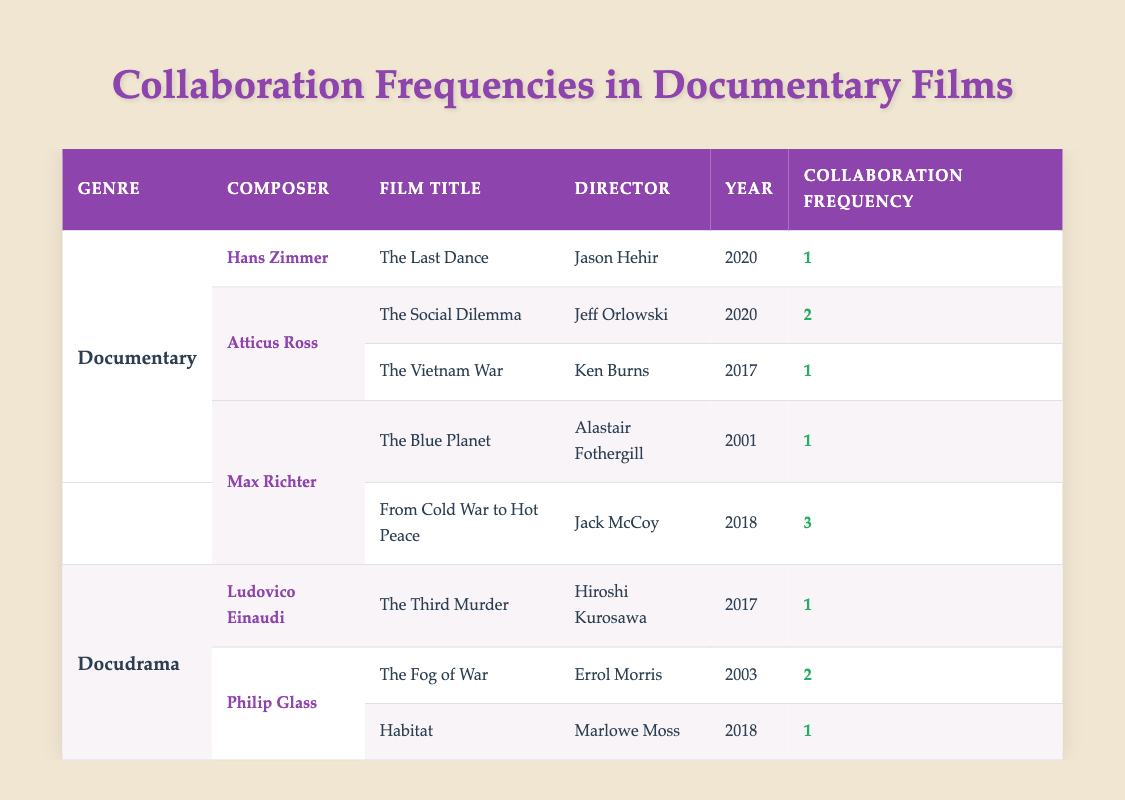What is the title of the film composed by Hans Zimmer? The table lists "The Last Dance" as the film composed by Hans Zimmer. This is found in the row corresponding to Hans Zimmer under the Documentary genre.
Answer: The Last Dance Which composer has worked on the film "The Fog of War"? The table shows that Philip Glass is the composer for "The Fog of War", which is listed in the row corresponding to Philip Glass under the Docudrama genre.
Answer: Philip Glass What is the collaboration frequency of Atticus Ross for "The Social Dilemma"? The table indicates a collaboration frequency of 2 for Atticus Ross on "The Social Dilemma", as noted in the corresponding cell under Collaboration Frequency.
Answer: 2 How many films did Max Richter score, and what is the total collaboration frequency? Max Richter scored 2 films: "The Blue Planet" (1) and "From Cold War to Hot Peace" (3). Adding these together, the total collaboration frequency is 1 + 3 = 4.
Answer: 4 Did Ludovico Einaudi collaborate with more than one filmmaker? The data shows that Ludovico Einaudi collaborated on only one film, "The Third Murder", thus the answer is no.
Answer: No Which composer has the highest collaboration frequency in the table, and what is that value? By examining the Collaboration Frequency values, Max Richter has the highest frequency of 3 for "From Cold War to Hot Peace". This is the max value among all frequencies listed.
Answer: 3 How many years apart were the documentaries "The Social Dilemma" and "The Vietnam War" released? "The Social Dilemma" was released in 2020 and "The Vietnam War" in 2017. The difference in years is 2020 - 2017 = 3 years.
Answer: 3 years Is there any composer who has collaborated on only one film, and if so, who are they? Both Hans Zimmer, Ludovico Einaudi, and Atticus Ross each collaborated on only one film, indicating that there are several composers who fit this criterion.
Answer: Yes, Hans Zimmer, Ludovico Einaudi, and Atticus Ross What is the average collaboration frequency for the composers in the Docudrama genre? In the Docudrama genre, Philip Glass has collaboration frequencies of 2 and 1, and Ludovico Einaudi has 1. Hence, the average is (2 + 1 + 1) / 3 = 4 / 3 = 1.33 (approximately 1.33).
Answer: 1.33 